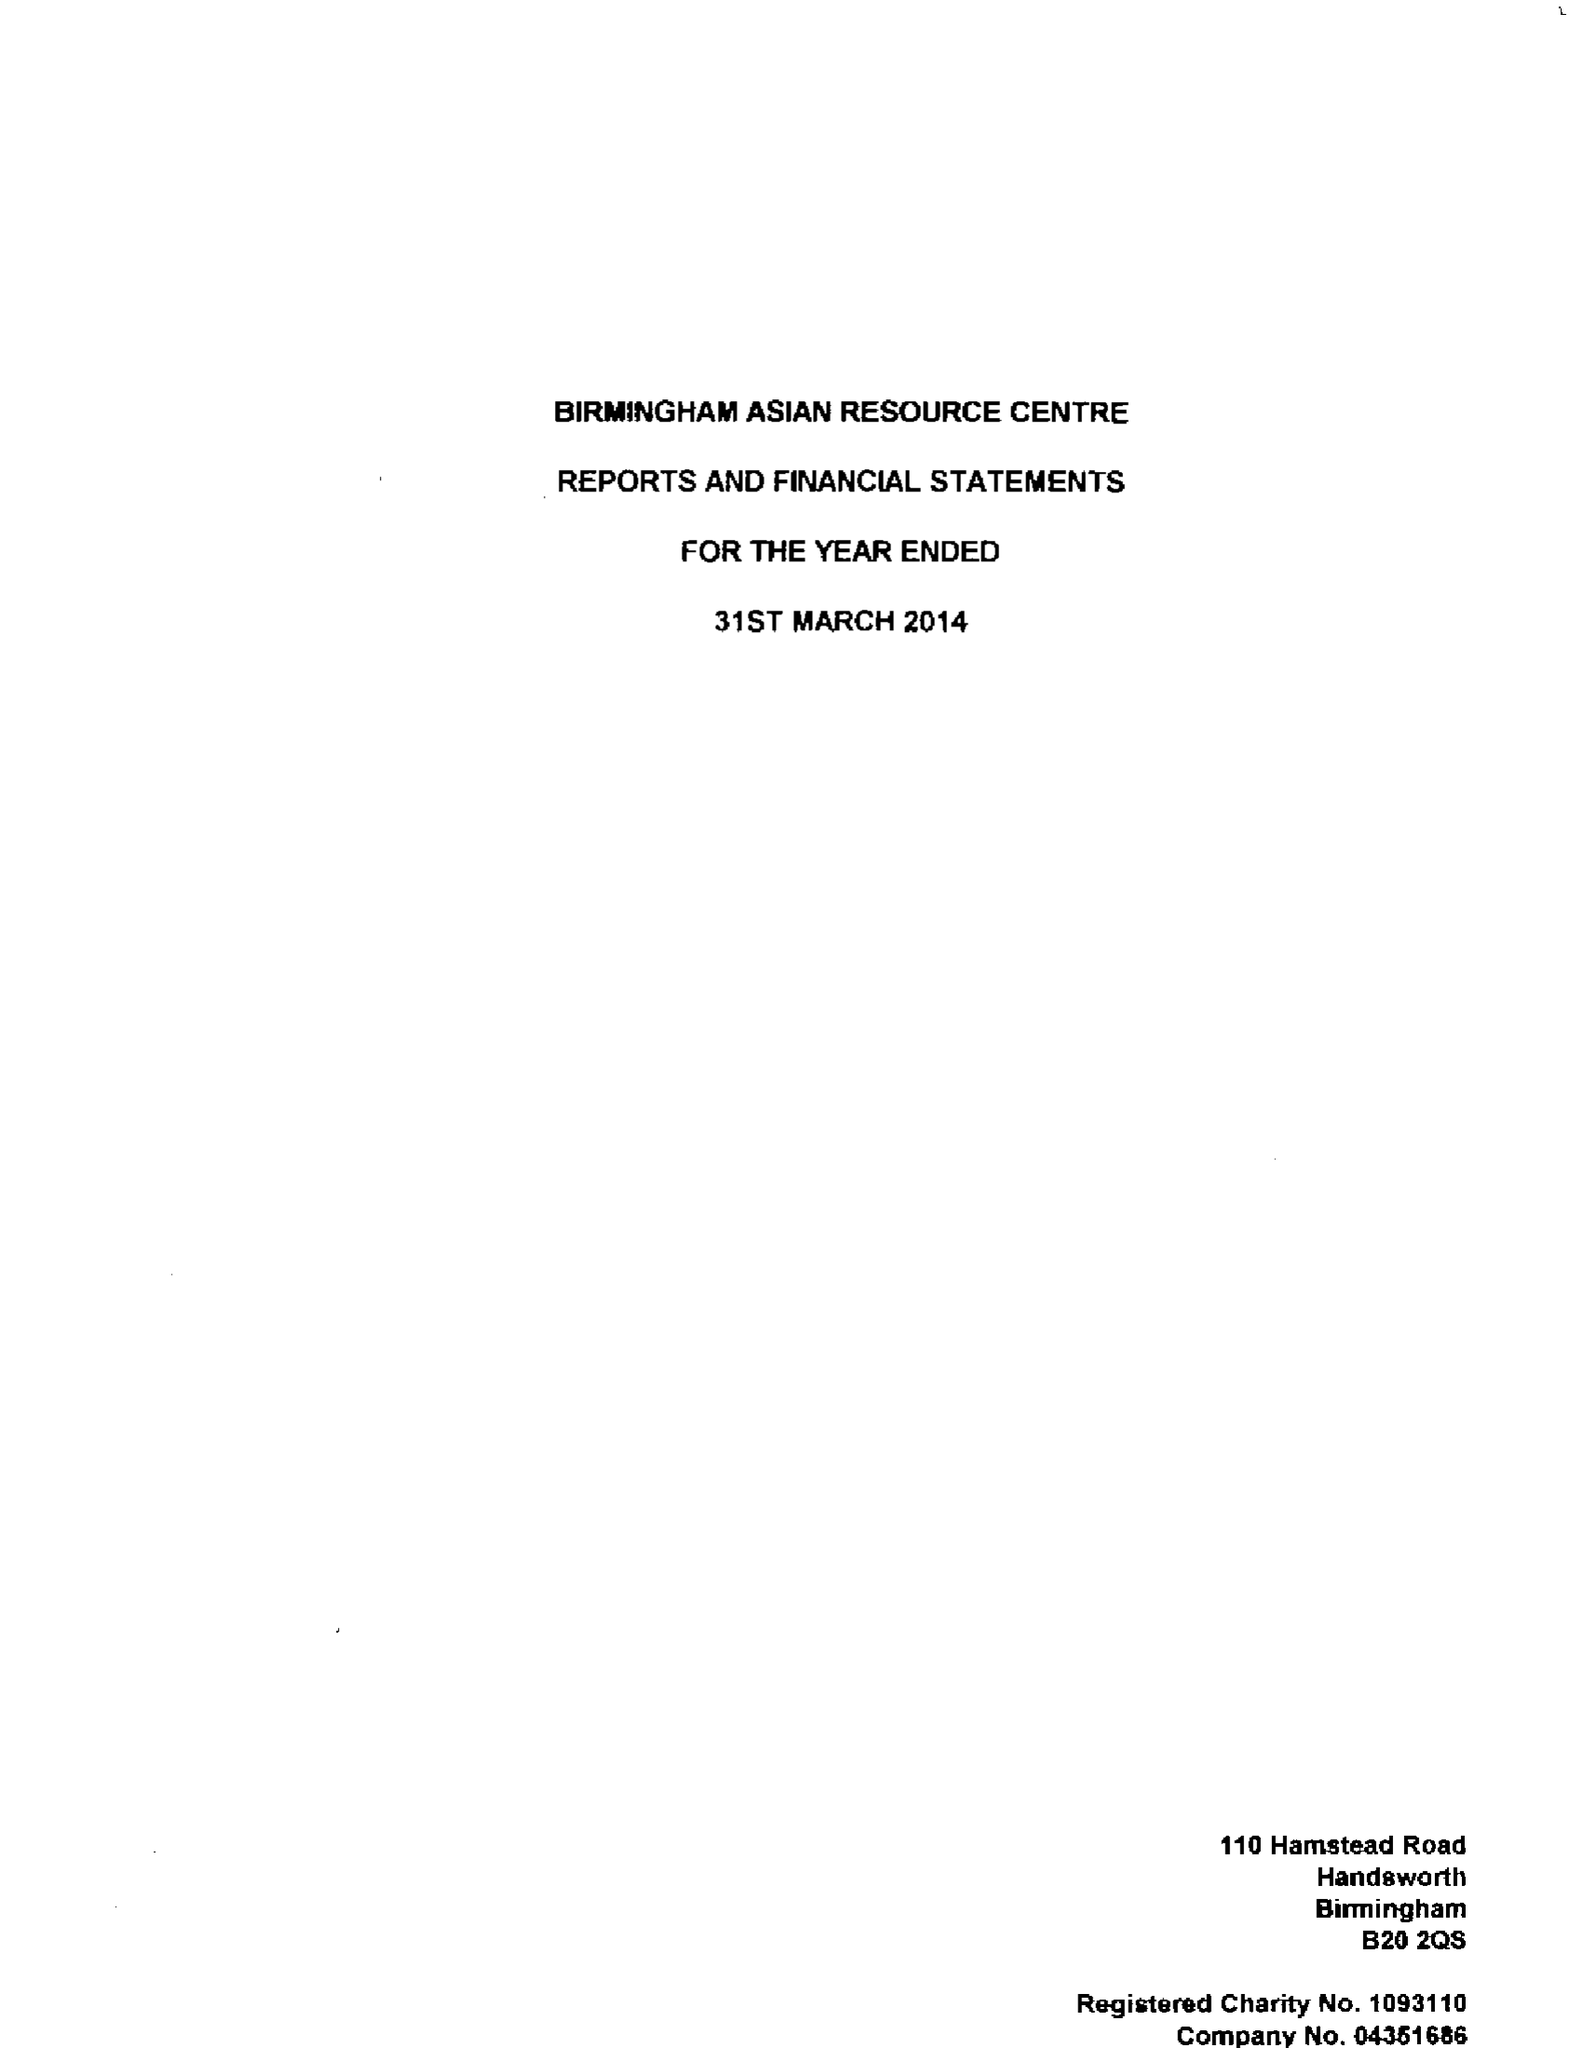What is the value for the charity_name?
Answer the question using a single word or phrase. Birmingham Asian Resource Centre 